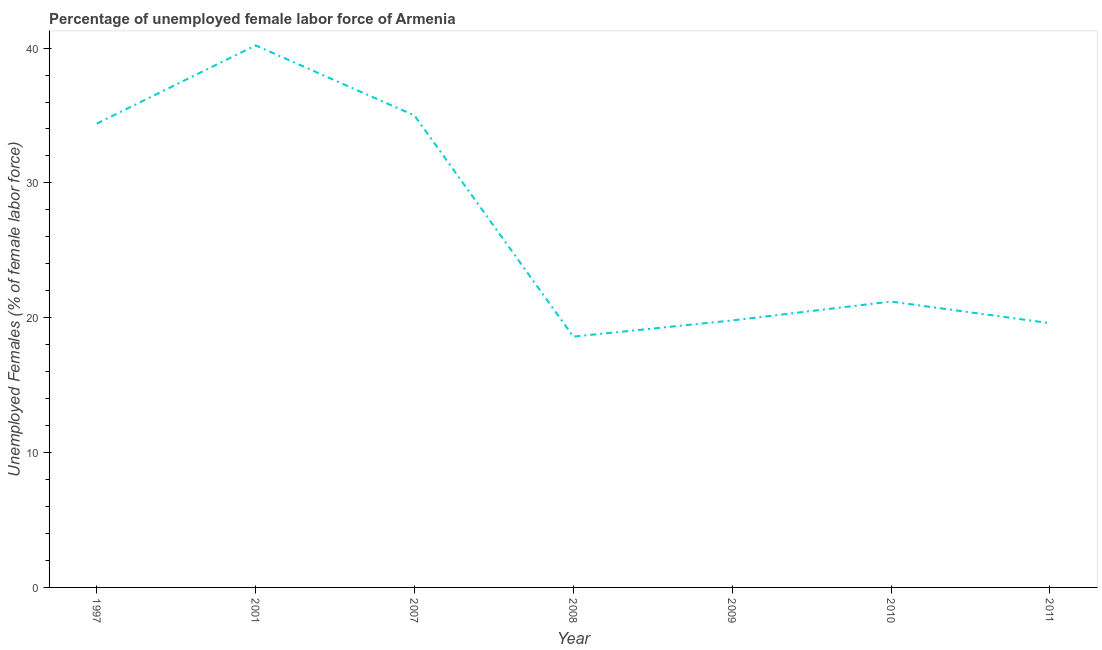What is the total unemployed female labour force in 2009?
Provide a succinct answer. 19.8. Across all years, what is the maximum total unemployed female labour force?
Provide a short and direct response. 40.2. Across all years, what is the minimum total unemployed female labour force?
Provide a short and direct response. 18.6. In which year was the total unemployed female labour force minimum?
Offer a terse response. 2008. What is the sum of the total unemployed female labour force?
Give a very brief answer. 188.8. What is the difference between the total unemployed female labour force in 1997 and 2011?
Provide a short and direct response. 14.8. What is the average total unemployed female labour force per year?
Keep it short and to the point. 26.97. What is the median total unemployed female labour force?
Give a very brief answer. 21.2. What is the ratio of the total unemployed female labour force in 2001 to that in 2007?
Make the answer very short. 1.15. Is the difference between the total unemployed female labour force in 2001 and 2010 greater than the difference between any two years?
Your answer should be very brief. No. What is the difference between the highest and the second highest total unemployed female labour force?
Your answer should be very brief. 5.2. What is the difference between the highest and the lowest total unemployed female labour force?
Make the answer very short. 21.6. Does the total unemployed female labour force monotonically increase over the years?
Offer a very short reply. No. How many lines are there?
Your response must be concise. 1. Does the graph contain any zero values?
Keep it short and to the point. No. What is the title of the graph?
Provide a succinct answer. Percentage of unemployed female labor force of Armenia. What is the label or title of the Y-axis?
Offer a terse response. Unemployed Females (% of female labor force). What is the Unemployed Females (% of female labor force) of 1997?
Your response must be concise. 34.4. What is the Unemployed Females (% of female labor force) in 2001?
Your response must be concise. 40.2. What is the Unemployed Females (% of female labor force) in 2007?
Provide a short and direct response. 35. What is the Unemployed Females (% of female labor force) of 2008?
Give a very brief answer. 18.6. What is the Unemployed Females (% of female labor force) of 2009?
Provide a succinct answer. 19.8. What is the Unemployed Females (% of female labor force) in 2010?
Your response must be concise. 21.2. What is the Unemployed Females (% of female labor force) of 2011?
Give a very brief answer. 19.6. What is the difference between the Unemployed Females (% of female labor force) in 1997 and 2001?
Provide a succinct answer. -5.8. What is the difference between the Unemployed Females (% of female labor force) in 1997 and 2007?
Your response must be concise. -0.6. What is the difference between the Unemployed Females (% of female labor force) in 1997 and 2009?
Give a very brief answer. 14.6. What is the difference between the Unemployed Females (% of female labor force) in 1997 and 2010?
Make the answer very short. 13.2. What is the difference between the Unemployed Females (% of female labor force) in 1997 and 2011?
Your answer should be compact. 14.8. What is the difference between the Unemployed Females (% of female labor force) in 2001 and 2008?
Provide a succinct answer. 21.6. What is the difference between the Unemployed Females (% of female labor force) in 2001 and 2009?
Offer a very short reply. 20.4. What is the difference between the Unemployed Females (% of female labor force) in 2001 and 2010?
Keep it short and to the point. 19. What is the difference between the Unemployed Females (% of female labor force) in 2001 and 2011?
Offer a very short reply. 20.6. What is the difference between the Unemployed Females (% of female labor force) in 2007 and 2010?
Your response must be concise. 13.8. What is the difference between the Unemployed Females (% of female labor force) in 2007 and 2011?
Give a very brief answer. 15.4. What is the difference between the Unemployed Females (% of female labor force) in 2008 and 2009?
Keep it short and to the point. -1.2. What is the difference between the Unemployed Females (% of female labor force) in 2008 and 2011?
Make the answer very short. -1. What is the difference between the Unemployed Females (% of female labor force) in 2009 and 2010?
Offer a terse response. -1.4. What is the difference between the Unemployed Females (% of female labor force) in 2009 and 2011?
Provide a succinct answer. 0.2. What is the difference between the Unemployed Females (% of female labor force) in 2010 and 2011?
Give a very brief answer. 1.6. What is the ratio of the Unemployed Females (% of female labor force) in 1997 to that in 2001?
Offer a very short reply. 0.86. What is the ratio of the Unemployed Females (% of female labor force) in 1997 to that in 2008?
Your answer should be compact. 1.85. What is the ratio of the Unemployed Females (% of female labor force) in 1997 to that in 2009?
Provide a succinct answer. 1.74. What is the ratio of the Unemployed Females (% of female labor force) in 1997 to that in 2010?
Provide a succinct answer. 1.62. What is the ratio of the Unemployed Females (% of female labor force) in 1997 to that in 2011?
Keep it short and to the point. 1.75. What is the ratio of the Unemployed Females (% of female labor force) in 2001 to that in 2007?
Keep it short and to the point. 1.15. What is the ratio of the Unemployed Females (% of female labor force) in 2001 to that in 2008?
Give a very brief answer. 2.16. What is the ratio of the Unemployed Females (% of female labor force) in 2001 to that in 2009?
Your answer should be compact. 2.03. What is the ratio of the Unemployed Females (% of female labor force) in 2001 to that in 2010?
Keep it short and to the point. 1.9. What is the ratio of the Unemployed Females (% of female labor force) in 2001 to that in 2011?
Your answer should be very brief. 2.05. What is the ratio of the Unemployed Females (% of female labor force) in 2007 to that in 2008?
Your answer should be compact. 1.88. What is the ratio of the Unemployed Females (% of female labor force) in 2007 to that in 2009?
Offer a terse response. 1.77. What is the ratio of the Unemployed Females (% of female labor force) in 2007 to that in 2010?
Offer a very short reply. 1.65. What is the ratio of the Unemployed Females (% of female labor force) in 2007 to that in 2011?
Your response must be concise. 1.79. What is the ratio of the Unemployed Females (% of female labor force) in 2008 to that in 2009?
Your answer should be compact. 0.94. What is the ratio of the Unemployed Females (% of female labor force) in 2008 to that in 2010?
Your answer should be compact. 0.88. What is the ratio of the Unemployed Females (% of female labor force) in 2008 to that in 2011?
Offer a terse response. 0.95. What is the ratio of the Unemployed Females (% of female labor force) in 2009 to that in 2010?
Make the answer very short. 0.93. What is the ratio of the Unemployed Females (% of female labor force) in 2009 to that in 2011?
Keep it short and to the point. 1.01. What is the ratio of the Unemployed Females (% of female labor force) in 2010 to that in 2011?
Provide a succinct answer. 1.08. 